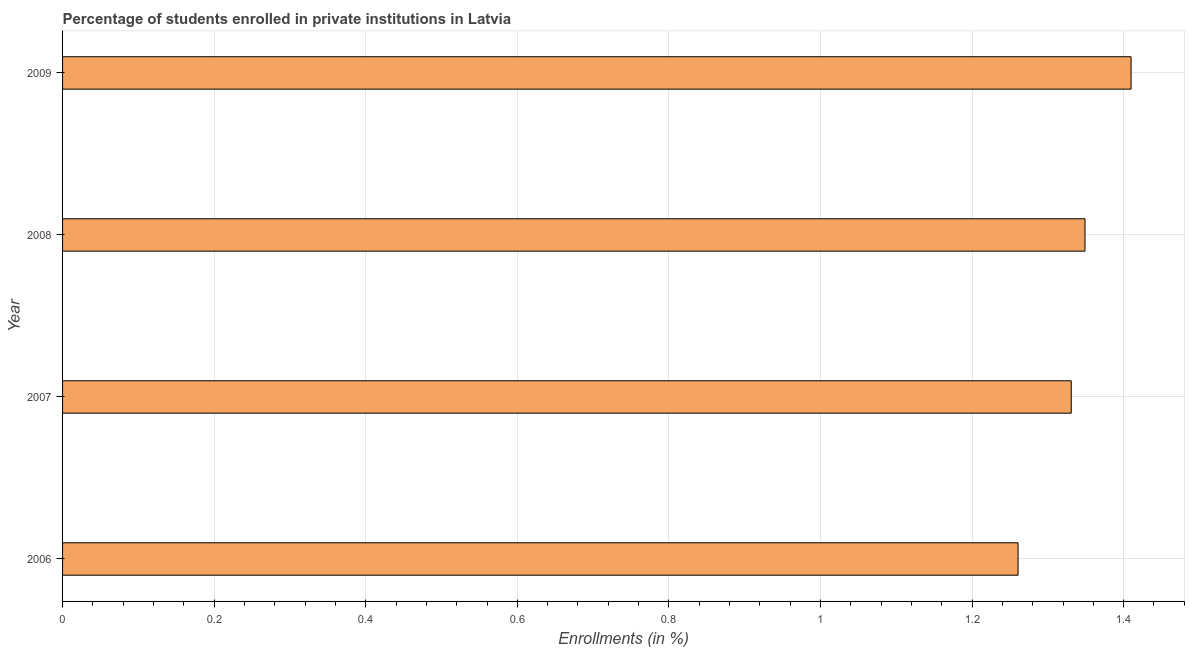Does the graph contain grids?
Make the answer very short. Yes. What is the title of the graph?
Your response must be concise. Percentage of students enrolled in private institutions in Latvia. What is the label or title of the X-axis?
Your answer should be very brief. Enrollments (in %). What is the enrollments in private institutions in 2006?
Keep it short and to the point. 1.26. Across all years, what is the maximum enrollments in private institutions?
Offer a terse response. 1.41. Across all years, what is the minimum enrollments in private institutions?
Keep it short and to the point. 1.26. In which year was the enrollments in private institutions minimum?
Your answer should be compact. 2006. What is the sum of the enrollments in private institutions?
Ensure brevity in your answer.  5.35. What is the difference between the enrollments in private institutions in 2006 and 2008?
Make the answer very short. -0.09. What is the average enrollments in private institutions per year?
Offer a very short reply. 1.34. What is the median enrollments in private institutions?
Make the answer very short. 1.34. In how many years, is the enrollments in private institutions greater than 1 %?
Your answer should be very brief. 4. What is the difference between the highest and the second highest enrollments in private institutions?
Offer a terse response. 0.06. What is the difference between the highest and the lowest enrollments in private institutions?
Keep it short and to the point. 0.15. How many bars are there?
Provide a short and direct response. 4. What is the difference between two consecutive major ticks on the X-axis?
Ensure brevity in your answer.  0.2. Are the values on the major ticks of X-axis written in scientific E-notation?
Your response must be concise. No. What is the Enrollments (in %) of 2006?
Ensure brevity in your answer.  1.26. What is the Enrollments (in %) in 2007?
Ensure brevity in your answer.  1.33. What is the Enrollments (in %) of 2008?
Keep it short and to the point. 1.35. What is the Enrollments (in %) in 2009?
Your response must be concise. 1.41. What is the difference between the Enrollments (in %) in 2006 and 2007?
Your response must be concise. -0.07. What is the difference between the Enrollments (in %) in 2006 and 2008?
Offer a very short reply. -0.09. What is the difference between the Enrollments (in %) in 2006 and 2009?
Give a very brief answer. -0.15. What is the difference between the Enrollments (in %) in 2007 and 2008?
Ensure brevity in your answer.  -0.02. What is the difference between the Enrollments (in %) in 2007 and 2009?
Give a very brief answer. -0.08. What is the difference between the Enrollments (in %) in 2008 and 2009?
Offer a very short reply. -0.06. What is the ratio of the Enrollments (in %) in 2006 to that in 2007?
Your answer should be compact. 0.95. What is the ratio of the Enrollments (in %) in 2006 to that in 2008?
Give a very brief answer. 0.94. What is the ratio of the Enrollments (in %) in 2006 to that in 2009?
Provide a succinct answer. 0.89. What is the ratio of the Enrollments (in %) in 2007 to that in 2008?
Keep it short and to the point. 0.99. What is the ratio of the Enrollments (in %) in 2007 to that in 2009?
Offer a terse response. 0.94. What is the ratio of the Enrollments (in %) in 2008 to that in 2009?
Your response must be concise. 0.96. 